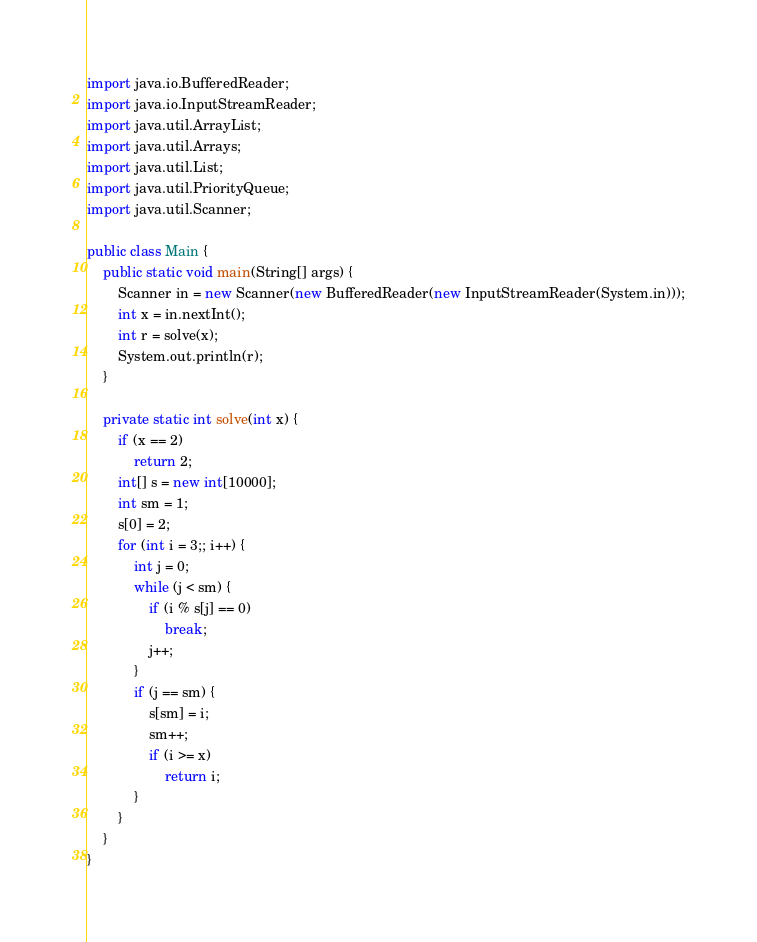Convert code to text. <code><loc_0><loc_0><loc_500><loc_500><_Java_>import java.io.BufferedReader;
import java.io.InputStreamReader;
import java.util.ArrayList;
import java.util.Arrays;
import java.util.List;
import java.util.PriorityQueue;
import java.util.Scanner;

public class Main {
	public static void main(String[] args) {
		Scanner in = new Scanner(new BufferedReader(new InputStreamReader(System.in)));
		int x = in.nextInt();
		int r = solve(x);
		System.out.println(r);
	}

	private static int solve(int x) {
		if (x == 2)
			return 2;
		int[] s = new int[10000];
		int sm = 1;
		s[0] = 2;
		for (int i = 3;; i++) {
			int j = 0;
			while (j < sm) {
				if (i % s[j] == 0)
					break;
				j++;
			}
			if (j == sm) {
				s[sm] = i;
				sm++;
				if (i >= x)
					return i;
			}
		}
	}
}</code> 